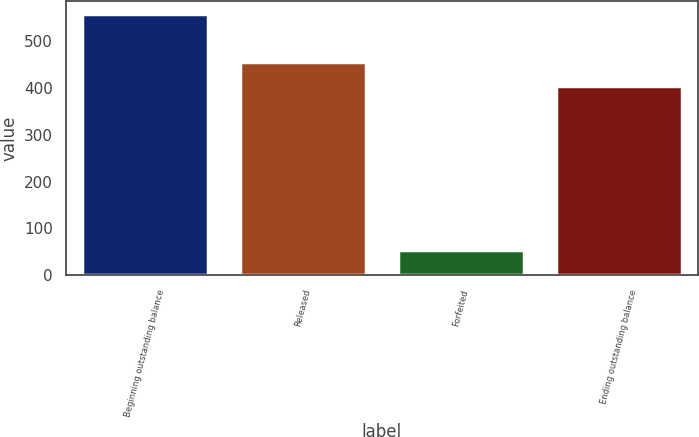<chart> <loc_0><loc_0><loc_500><loc_500><bar_chart><fcel>Beginning outstanding balance<fcel>Released<fcel>Forfeited<fcel>Ending outstanding balance<nl><fcel>557<fcel>455.4<fcel>53<fcel>405<nl></chart> 